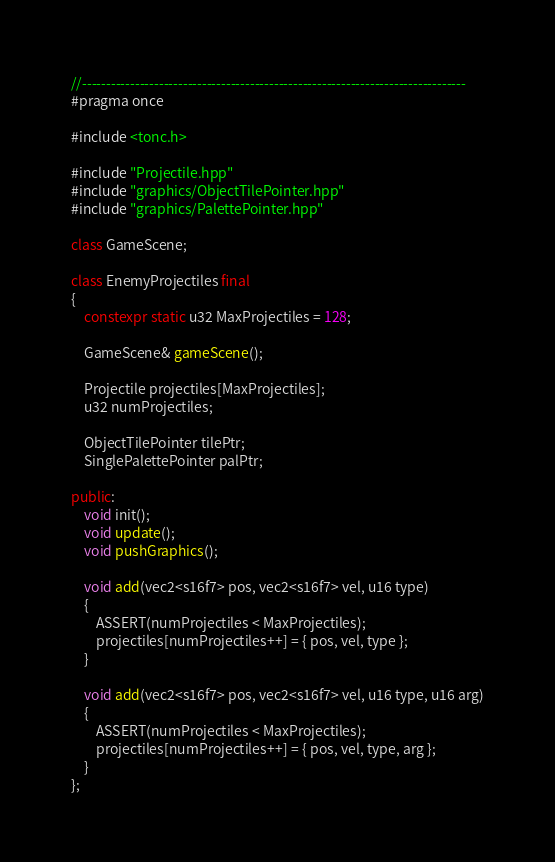<code> <loc_0><loc_0><loc_500><loc_500><_C++_>//--------------------------------------------------------------------------------
#pragma once

#include <tonc.h>

#include "Projectile.hpp"
#include "graphics/ObjectTilePointer.hpp"
#include "graphics/PalettePointer.hpp"

class GameScene;

class EnemyProjectiles final
{
    constexpr static u32 MaxProjectiles = 128;

    GameScene& gameScene();

    Projectile projectiles[MaxProjectiles];
    u32 numProjectiles;

    ObjectTilePointer tilePtr;
    SinglePalettePointer palPtr;

public:
    void init();
    void update();
    void pushGraphics();

    void add(vec2<s16f7> pos, vec2<s16f7> vel, u16 type)
    {
        ASSERT(numProjectiles < MaxProjectiles);
        projectiles[numProjectiles++] = { pos, vel, type };
    }

    void add(vec2<s16f7> pos, vec2<s16f7> vel, u16 type, u16 arg)
    {
        ASSERT(numProjectiles < MaxProjectiles);
        projectiles[numProjectiles++] = { pos, vel, type, arg };
    }
};

</code> 